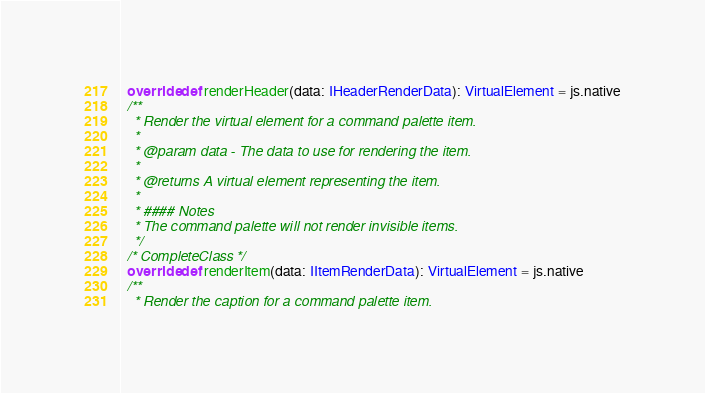<code> <loc_0><loc_0><loc_500><loc_500><_Scala_>  override def renderHeader(data: IHeaderRenderData): VirtualElement = js.native
  /**
    * Render the virtual element for a command palette item.
    *
    * @param data - The data to use for rendering the item.
    *
    * @returns A virtual element representing the item.
    *
    * #### Notes
    * The command palette will not render invisible items.
    */
  /* CompleteClass */
  override def renderItem(data: IItemRenderData): VirtualElement = js.native
  /**
    * Render the caption for a command palette item.</code> 